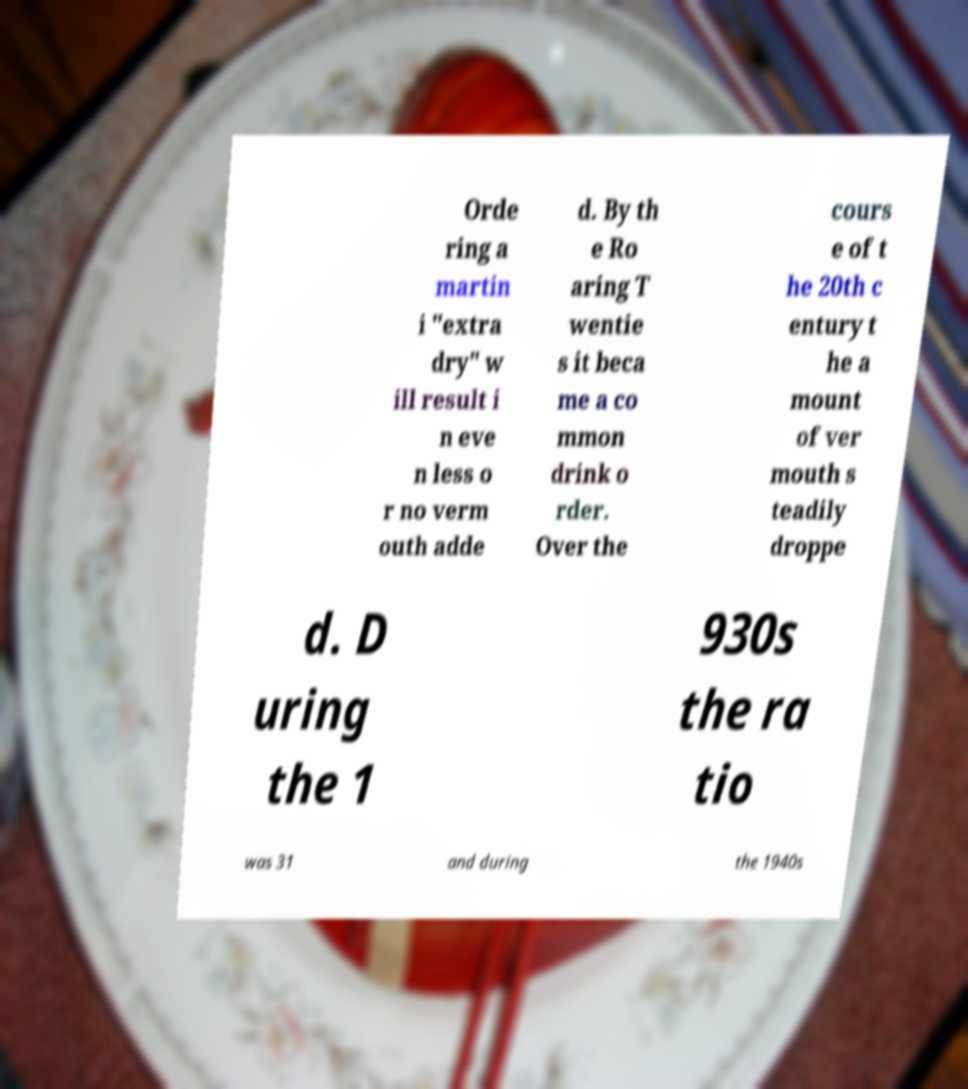Please identify and transcribe the text found in this image. Orde ring a martin i "extra dry" w ill result i n eve n less o r no verm outh adde d. By th e Ro aring T wentie s it beca me a co mmon drink o rder. Over the cours e of t he 20th c entury t he a mount of ver mouth s teadily droppe d. D uring the 1 930s the ra tio was 31 and during the 1940s 